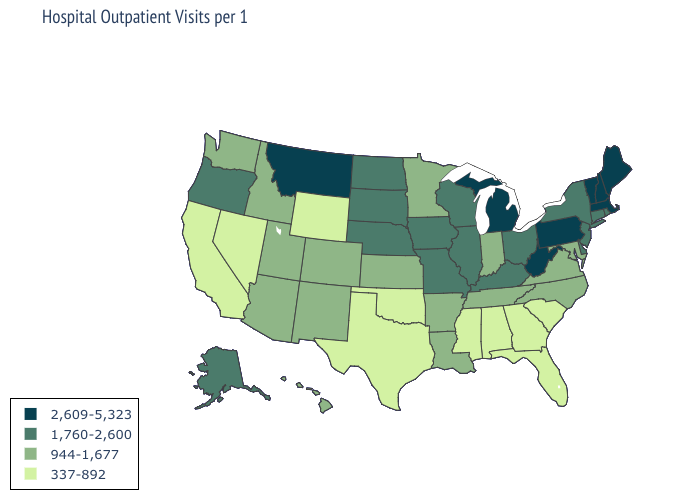Does Florida have the highest value in the South?
Concise answer only. No. What is the lowest value in states that border Tennessee?
Write a very short answer. 337-892. Name the states that have a value in the range 337-892?
Concise answer only. Alabama, California, Florida, Georgia, Mississippi, Nevada, Oklahoma, South Carolina, Texas, Wyoming. Name the states that have a value in the range 337-892?
Give a very brief answer. Alabama, California, Florida, Georgia, Mississippi, Nevada, Oklahoma, South Carolina, Texas, Wyoming. Name the states that have a value in the range 2,609-5,323?
Quick response, please. Maine, Massachusetts, Michigan, Montana, New Hampshire, Pennsylvania, Vermont, West Virginia. What is the lowest value in the USA?
Concise answer only. 337-892. What is the value of Rhode Island?
Write a very short answer. 1,760-2,600. What is the value of Nebraska?
Give a very brief answer. 1,760-2,600. Name the states that have a value in the range 2,609-5,323?
Concise answer only. Maine, Massachusetts, Michigan, Montana, New Hampshire, Pennsylvania, Vermont, West Virginia. Among the states that border Washington , which have the lowest value?
Short answer required. Idaho. Name the states that have a value in the range 2,609-5,323?
Be succinct. Maine, Massachusetts, Michigan, Montana, New Hampshire, Pennsylvania, Vermont, West Virginia. What is the value of New Mexico?
Quick response, please. 944-1,677. Which states hav the highest value in the Northeast?
Be succinct. Maine, Massachusetts, New Hampshire, Pennsylvania, Vermont. Does South Carolina have the same value as Mississippi?
Be succinct. Yes. 